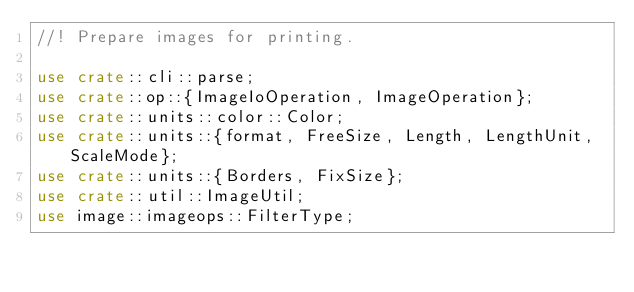<code> <loc_0><loc_0><loc_500><loc_500><_Rust_>//! Prepare images for printing.

use crate::cli::parse;
use crate::op::{ImageIoOperation, ImageOperation};
use crate::units::color::Color;
use crate::units::{format, FreeSize, Length, LengthUnit, ScaleMode};
use crate::units::{Borders, FixSize};
use crate::util::ImageUtil;
use image::imageops::FilterType;</code> 